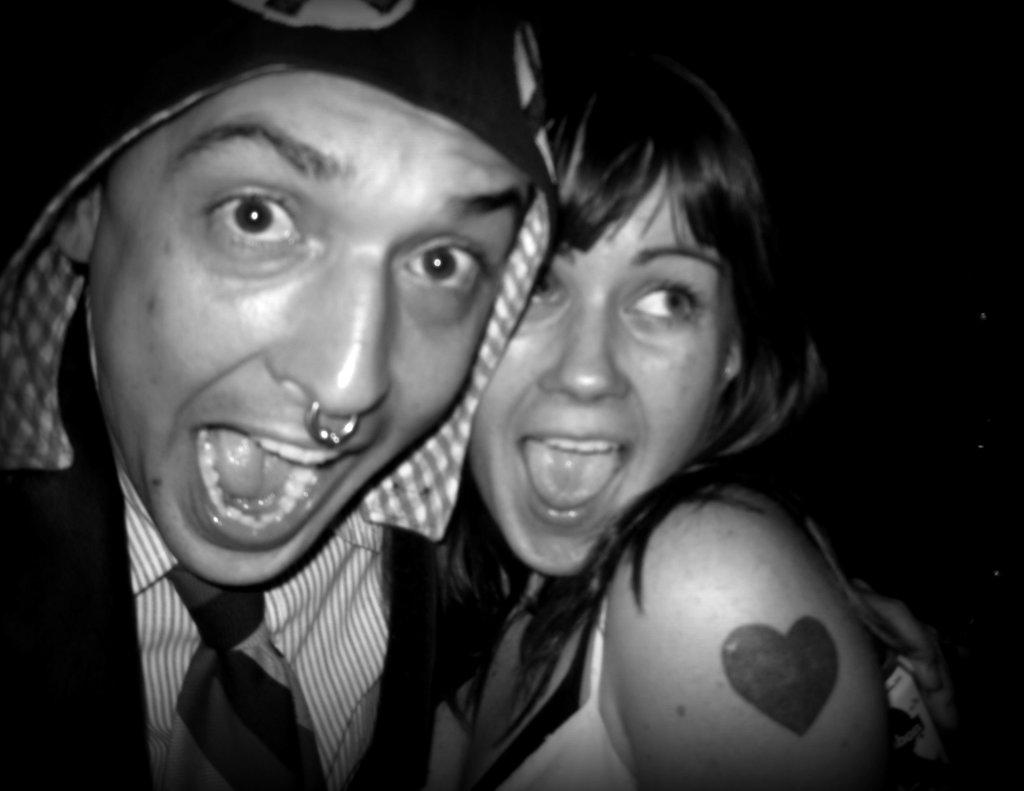How many people are present in the image? There is a man and a woman in the image. What is the color scheme of the image? The image is black and white in color. What type of ornament is the man holding in the image? There is no ornament present in the image. What kind of drum can be heard playing in the background of the image? There is no drum or sound present in the image, as it is a still photograph. 